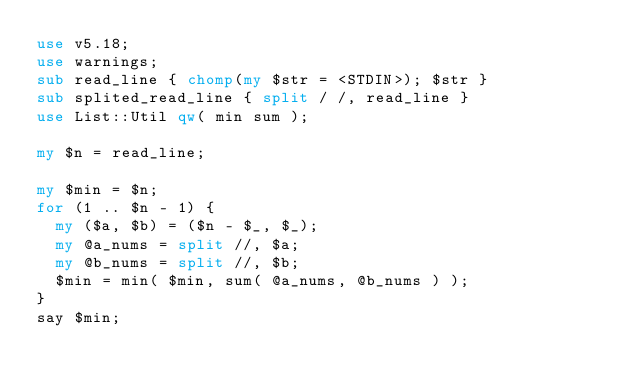<code> <loc_0><loc_0><loc_500><loc_500><_Perl_>use v5.18;
use warnings;
sub read_line { chomp(my $str = <STDIN>); $str }
sub splited_read_line { split / /, read_line }
use List::Util qw( min sum );

my $n = read_line;

my $min = $n;
for (1 .. $n - 1) {
  my ($a, $b) = ($n - $_, $_);
  my @a_nums = split //, $a;
  my @b_nums = split //, $b;
  $min = min( $min, sum( @a_nums, @b_nums ) );
}
say $min;
</code> 